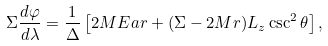<formula> <loc_0><loc_0><loc_500><loc_500>\Sigma \frac { d \varphi } { d \lambda } = \frac { 1 } { \Delta } \left [ 2 M E a r + ( \Sigma - 2 M r ) L _ { z } \csc ^ { 2 } \theta \right ] ,</formula> 